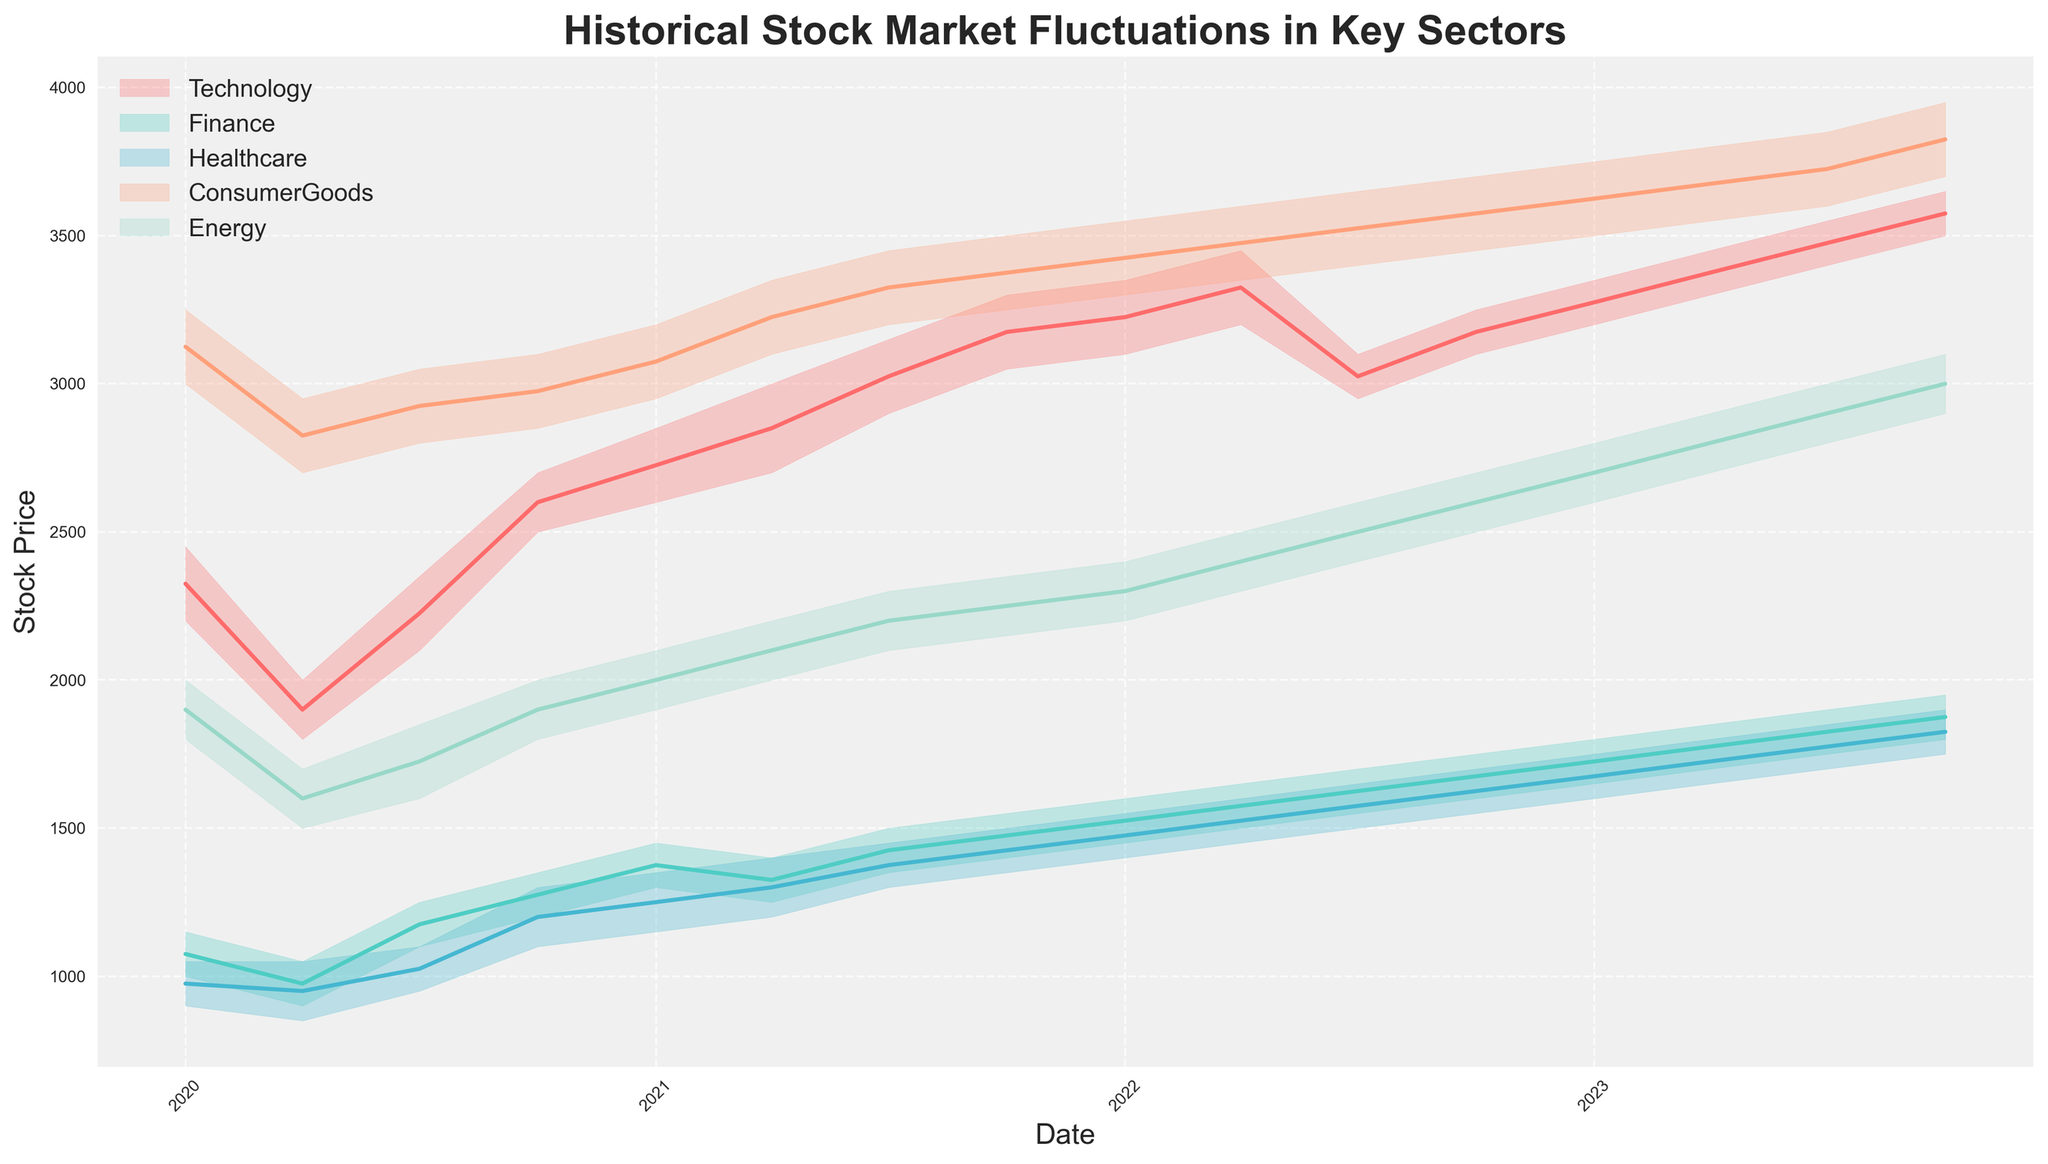What is the title of the chart? The title can be found at the top center of the chart. It reads 'Historical Stock Market Fluctuations in Key Sectors'.
Answer: Historical Stock Market Fluctuations in Key Sectors How do the x-axis labels represent the data? The x-axis is labeled with dates, which indicate the time points at which stock market fluctuations were recorded. The labels show years.
Answer: Dates/Years Which sector's stock has the highest price range during the time period? By observing the height of the filled area between the high and low lines for each sector, the ConsumerGoods sector has the widest range from 3,000 to 3,950 across the timeline.
Answer: ConsumerGoods Are there any trends noticeable in the Technology sector over time? The Technology sector starts with lower prices in early 2020 and shows a clear upward trend reaching its highest values in 2023, indicating continuous growth.
Answer: Continuous growth Which sector had the least fluctuation in stock prices in 2020? Comparing the vertical heights of the filled areas for each sector in 2020 (from January to December), the Finance sector shows the least fluctuation between 900-1350.
Answer: Finance What is the average high price for the Healthcare sector in 2021? The high prices for the Healthcare sector in 2021 are: 1350, 1400, 1450, 1500. Adding them gives 5700, and dividing by 4 gives 1425.
Answer: 1425 Which sector showed the least growth rate from 2020 to 2023? Comparing the difference between the high prices from the beginning to the end for each sector, the Finance sector goes from 1150 to 1950, which is a relatively smaller growth compared to others.
Answer: Finance How did the Energy sector perform in the third quarter (July) of 2022? Observing the filled area, the stock prices ranged from 2400 to 2600 in July 2022 for the Energy sector.
Answer: 2400 to 2600 In which year did the Healthcare sector cross the 1700 mark for its high prices? By tracking the high price line, it is noticeable that in 2023, the Healthcare sector's high prices crossed the 1700 mark starting in January.
Answer: 2023 Which sector had the highest minimum price in the first quarter of 2023? In the first quarter of 2023 (January), comparing the low prices of each sector, the ConsumerGoods sector had the highest at 3500.
Answer: ConsumerGoods 